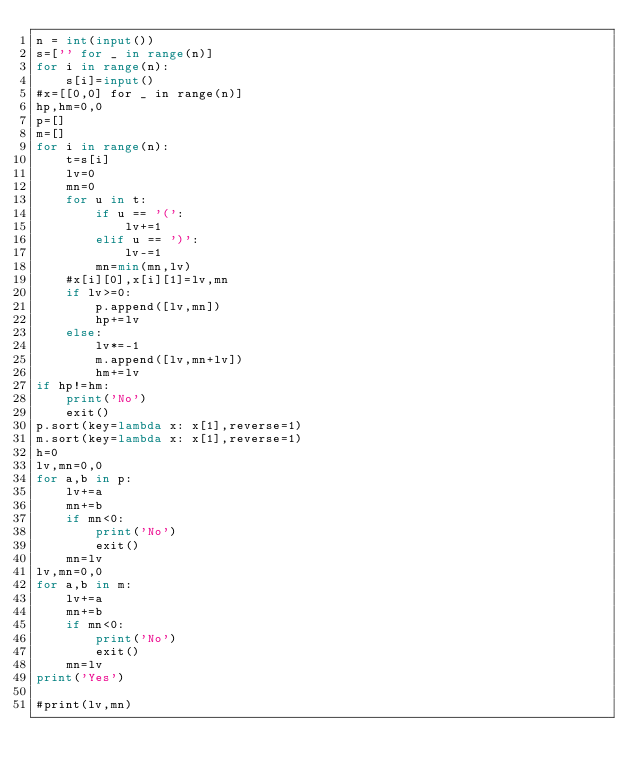Convert code to text. <code><loc_0><loc_0><loc_500><loc_500><_Python_>n = int(input())
s=['' for _ in range(n)]
for i in range(n):
    s[i]=input()
#x=[[0,0] for _ in range(n)]
hp,hm=0,0
p=[]
m=[]
for i in range(n):
    t=s[i]
    lv=0
    mn=0
    for u in t:
        if u == '(':
            lv+=1
        elif u == ')':
            lv-=1
        mn=min(mn,lv)
    #x[i][0],x[i][1]=lv,mn
    if lv>=0:
        p.append([lv,mn])
        hp+=lv
    else:
        lv*=-1
        m.append([lv,mn+lv])
        hm+=lv
if hp!=hm:
    print('No')
    exit()
p.sort(key=lambda x: x[1],reverse=1)
m.sort(key=lambda x: x[1],reverse=1)
h=0
lv,mn=0,0
for a,b in p:
    lv+=a
    mn+=b
    if mn<0:
        print('No')
        exit()
    mn=lv
lv,mn=0,0
for a,b in m:
    lv+=a
    mn+=b
    if mn<0:
        print('No')
        exit()
    mn=lv
print('Yes')

#print(lv,mn)
    
</code> 